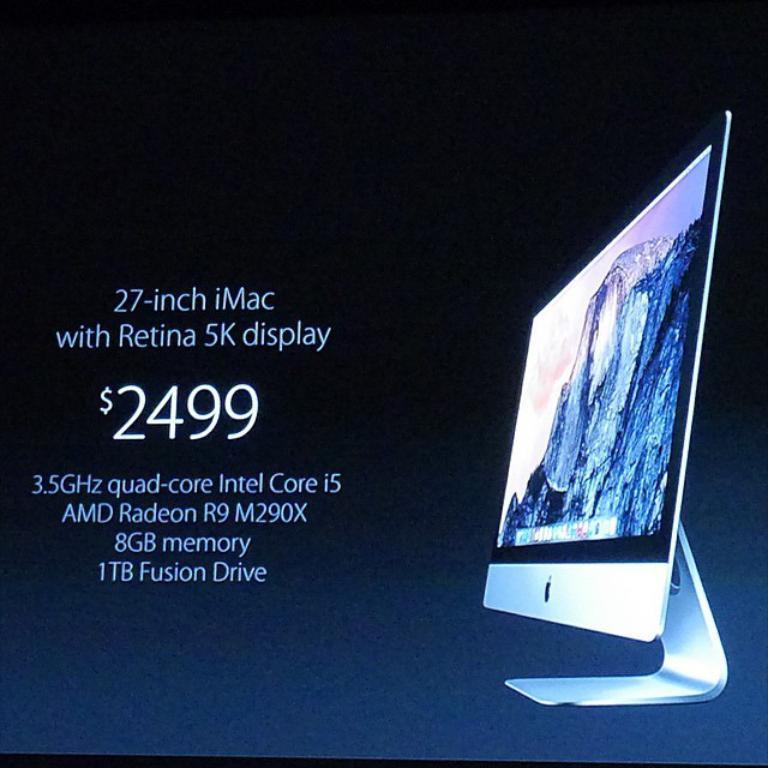<image>
Write a terse but informative summary of the picture. an ad for a computer screen costing 2499 dollars 